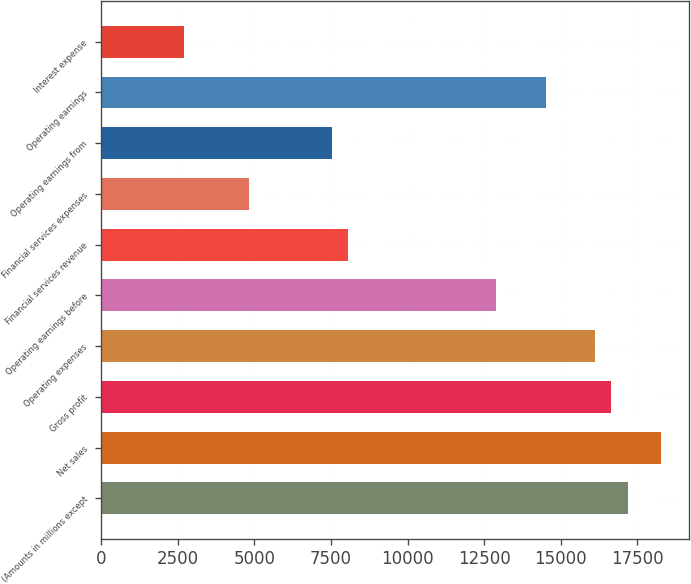<chart> <loc_0><loc_0><loc_500><loc_500><bar_chart><fcel>(Amounts in millions except<fcel>Net sales<fcel>Gross profit<fcel>Operating expenses<fcel>Operating earnings before<fcel>Financial services revenue<fcel>Financial services expenses<fcel>Operating earnings from<fcel>Operating earnings<fcel>Interest expense<nl><fcel>17192.4<fcel>18266.9<fcel>16655.1<fcel>16117.9<fcel>12894.5<fcel>8059.3<fcel>4835.86<fcel>7522.06<fcel>14506.2<fcel>2686.9<nl></chart> 